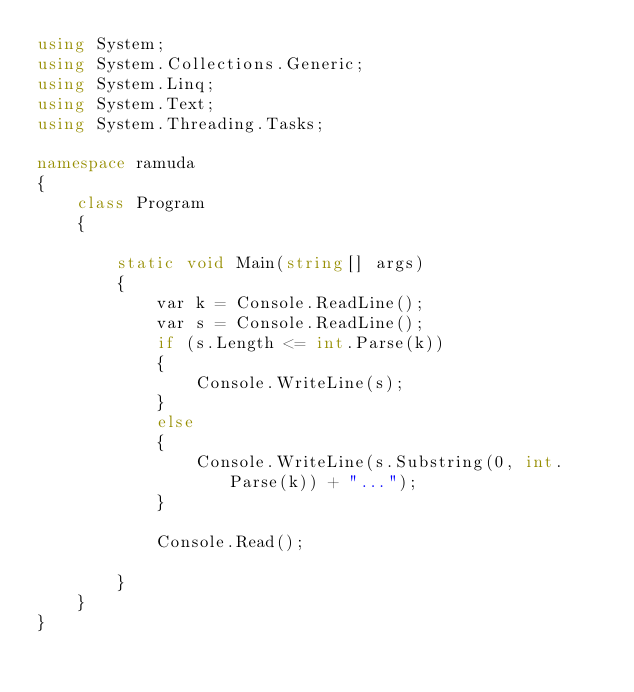Convert code to text. <code><loc_0><loc_0><loc_500><loc_500><_C#_>using System;
using System.Collections.Generic;
using System.Linq;
using System.Text;
using System.Threading.Tasks;

namespace ramuda
{ 
    class Program
    {

        static void Main(string[] args)
        {
            var k = Console.ReadLine();
            var s = Console.ReadLine();
            if (s.Length <= int.Parse(k))
            {
                Console.WriteLine(s);
            }
            else
            {
                Console.WriteLine(s.Substring(0, int.Parse(k)) + "...");
            }

            Console.Read();

        }
    }
}
</code> 